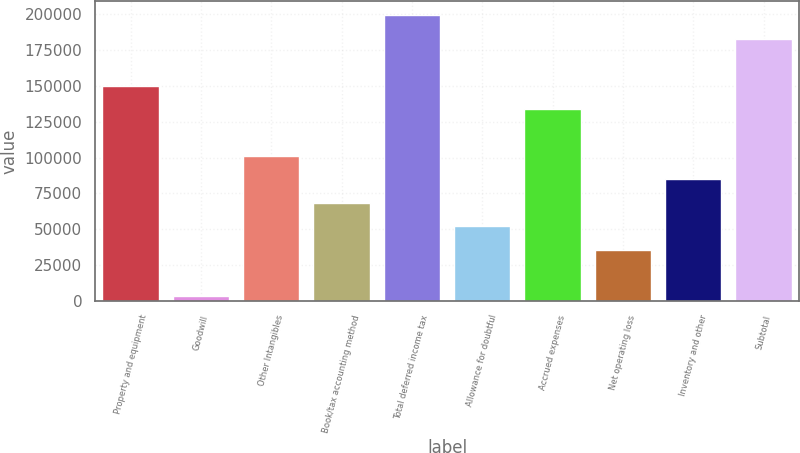Convert chart to OTSL. <chart><loc_0><loc_0><loc_500><loc_500><bar_chart><fcel>Property and equipment<fcel>Goodwill<fcel>Other Intangibles<fcel>Book/tax accounting method<fcel>Total deferred income tax<fcel>Allowance for doubtful<fcel>Accrued expenses<fcel>Net operating loss<fcel>Inventory and other<fcel>Subtotal<nl><fcel>150272<fcel>3041<fcel>101195<fcel>68477<fcel>199349<fcel>52118<fcel>133913<fcel>35759<fcel>84836<fcel>182990<nl></chart> 